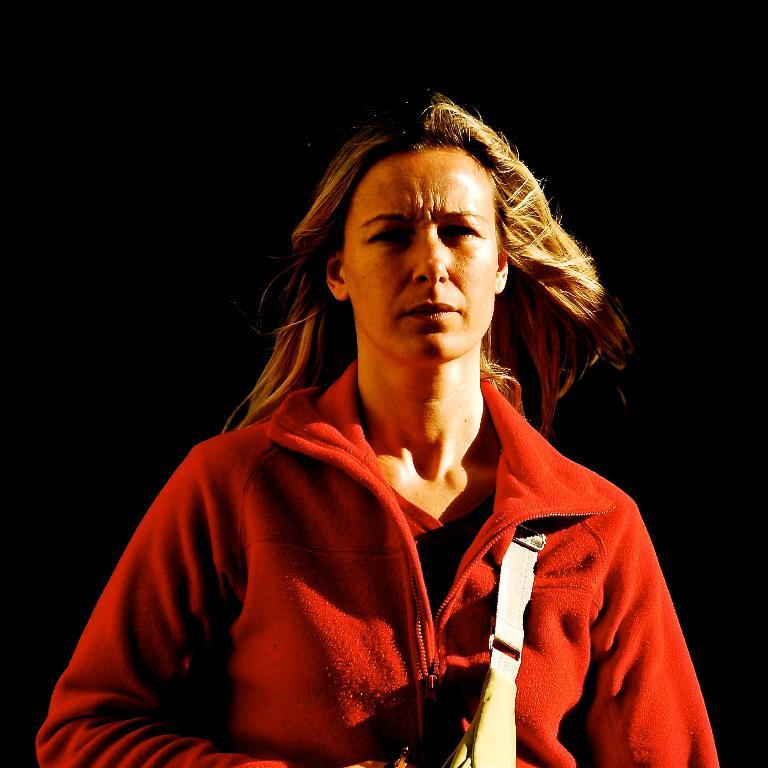What is the main subject of the image? The main subject of the image is a woman. What is the woman wearing in the image? The woman is wearing a red coat in the image. What is the woman carrying in the image? The woman is carrying a bag in the image. Can you see a locket around the woman's neck in the image? There is no locket visible around the woman's neck in the image. What type of cracker is the woman eating in the image? There is no cracker present in the image. 